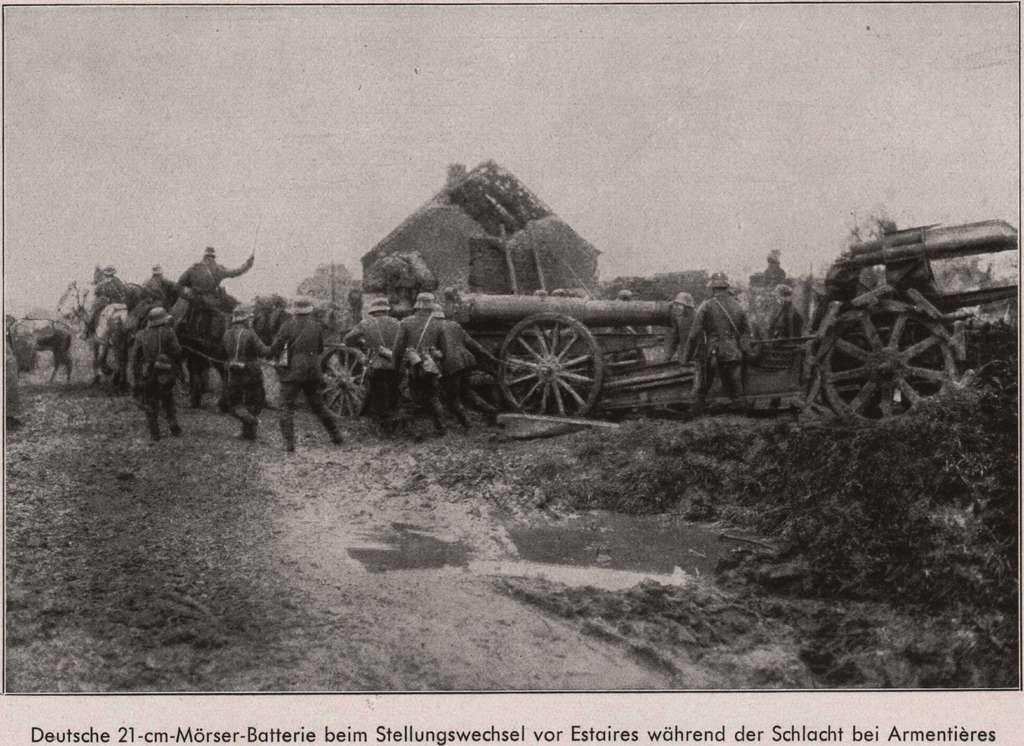What is the color scheme of the image? The image is black and white. What are the persons in the image doing? The persons are standing on the ground and drawing carts. What structures can be seen in the background of the image? There are buildings visible in the image. What part of the natural environment is visible in the image? The sky is visible in the image. Can you see any cobwebs hanging from the buildings in the image? There is no mention of cobwebs in the image, so we cannot determine their presence. What type of art is being created by the persons in the image? The image does not provide enough information to determine the type of art being created by the persons drawing carts. 